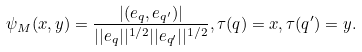<formula> <loc_0><loc_0><loc_500><loc_500>\psi _ { M } ( x , y ) = \frac { | ( e _ { q } , e _ { q ^ { \prime } } ) | } { | | e _ { q } | | ^ { 1 / 2 } | | e _ { q ^ { \prime } } | | ^ { 1 / 2 } } , \tau ( q ) = x , \tau ( q ^ { \prime } ) = y .</formula> 